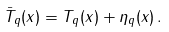Convert formula to latex. <formula><loc_0><loc_0><loc_500><loc_500>\bar { T } _ { q } ( x ) = T _ { q } ( x ) + \eta _ { q } ( x ) \, .</formula> 